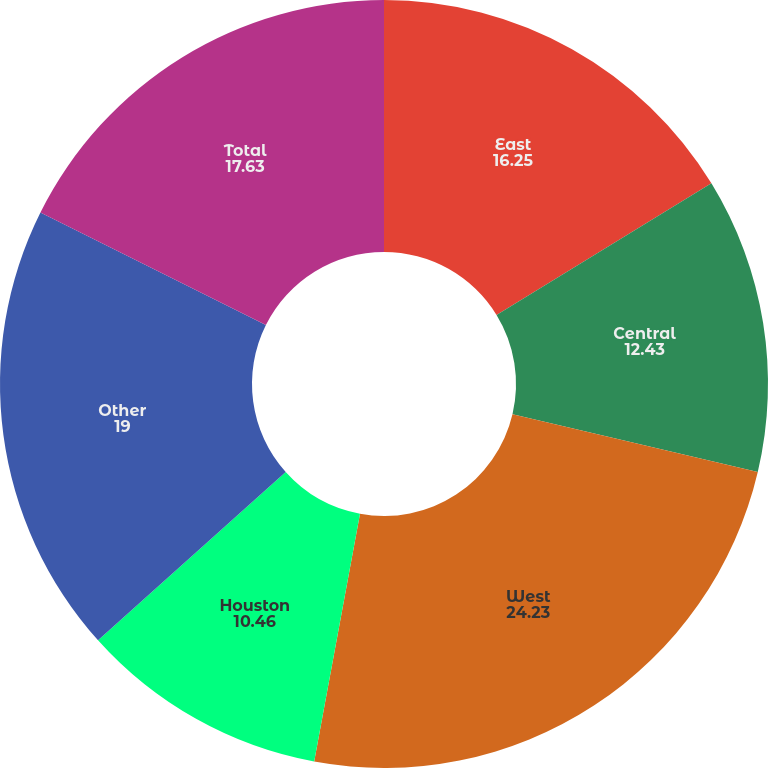Convert chart to OTSL. <chart><loc_0><loc_0><loc_500><loc_500><pie_chart><fcel>East<fcel>Central<fcel>West<fcel>Houston<fcel>Other<fcel>Total<nl><fcel>16.25%<fcel>12.43%<fcel>24.23%<fcel>10.46%<fcel>19.0%<fcel>17.63%<nl></chart> 